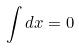Convert formula to latex. <formula><loc_0><loc_0><loc_500><loc_500>\int d x = 0</formula> 